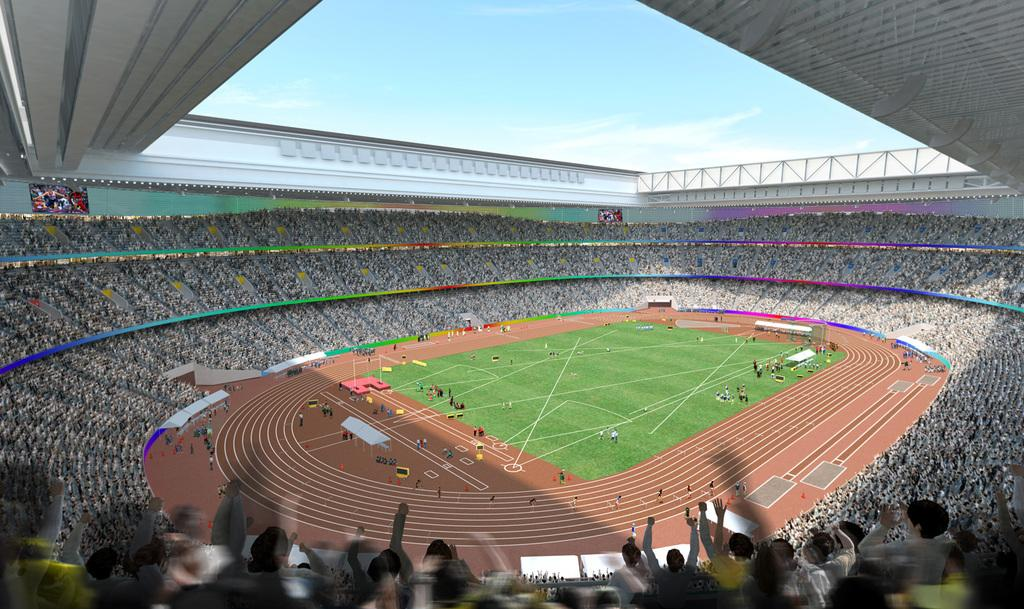Who or what can be seen in the image? There are people in the image. What is on the ground in the image? There are objects on the ground in the image. What is unique about the running track in the image? There are flags on the running track. Where are the people in the stands located? The people in the stands are located above the running track. What can be seen in the sky in the image? The sky is visible in the image. What verse is being recited by the people in the image? There is no indication in the image that people are reciting a verse, so it cannot be determined from the image. 